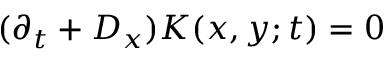Convert formula to latex. <formula><loc_0><loc_0><loc_500><loc_500>( \partial _ { t } + D _ { x } ) K ( x , y ; t ) = 0</formula> 